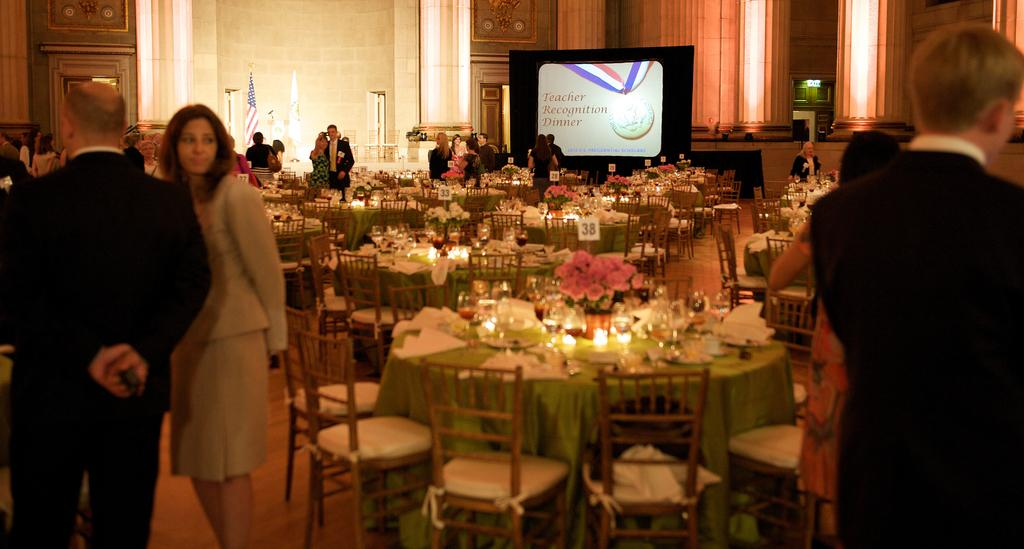What can be seen in the image involving people? There are people standing in the image. What type of furniture is present in the image? There is a table and a chair in the image. What items are on the table? There are wine glasses, plates, and food items on the table. What can be seen in the image related to lighting? There are lightings in the image. How many girls from a different nation are wearing hats in the image? There are no girls or hats mentioned in the provided facts, so this information cannot be determined from the image. 